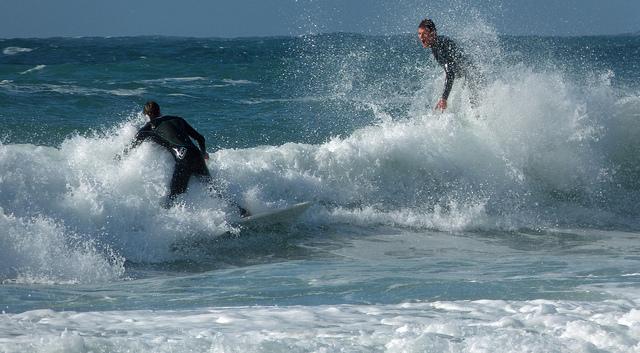How many people are surfing?
Keep it brief. 2. What color shirt is the surfer on the left wearing?
Keep it brief. Black. Are the waves so strong?
Be succinct. Yes. How many people are there?
Be succinct. 2. Are there any sharks in this photo?
Short answer required. No. 